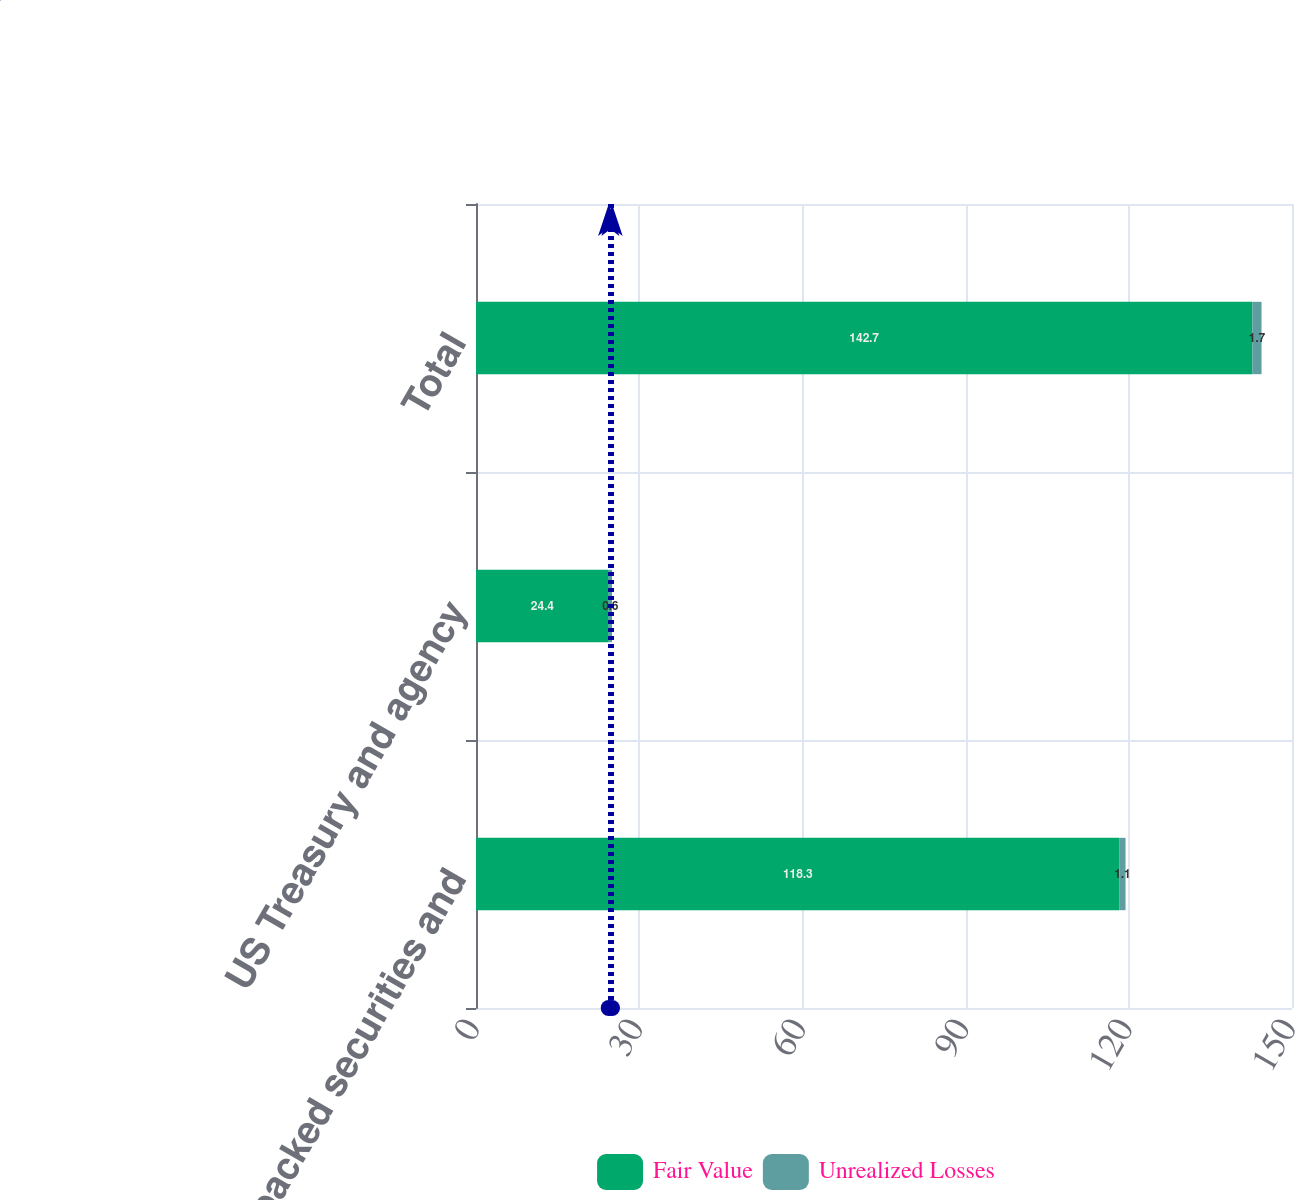Convert chart. <chart><loc_0><loc_0><loc_500><loc_500><stacked_bar_chart><ecel><fcel>Mortgage-backed securities and<fcel>US Treasury and agency<fcel>Total<nl><fcel>Fair Value<fcel>118.3<fcel>24.4<fcel>142.7<nl><fcel>Unrealized Losses<fcel>1.1<fcel>0.6<fcel>1.7<nl></chart> 